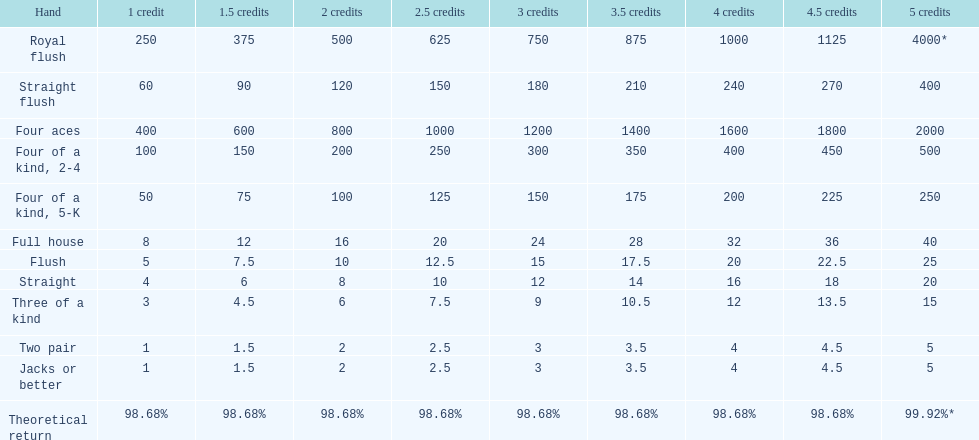What's the best type of four of a kind to win? Four of a kind, 2-4. 